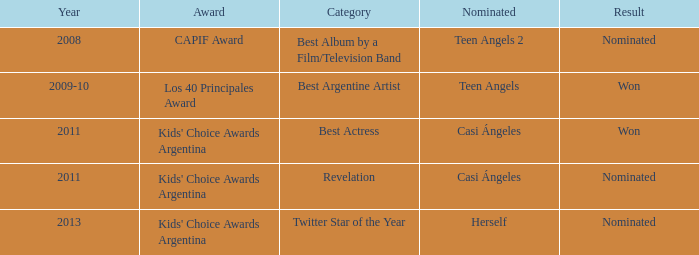For what award was there a nomination for Best Actress? Kids' Choice Awards Argentina. 